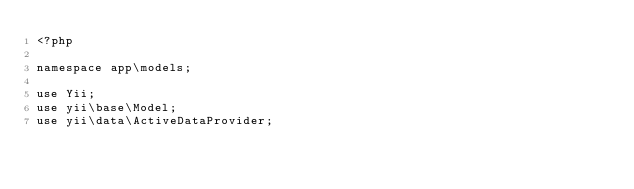Convert code to text. <code><loc_0><loc_0><loc_500><loc_500><_PHP_><?php

namespace app\models;

use Yii;
use yii\base\Model;
use yii\data\ActiveDataProvider;</code> 